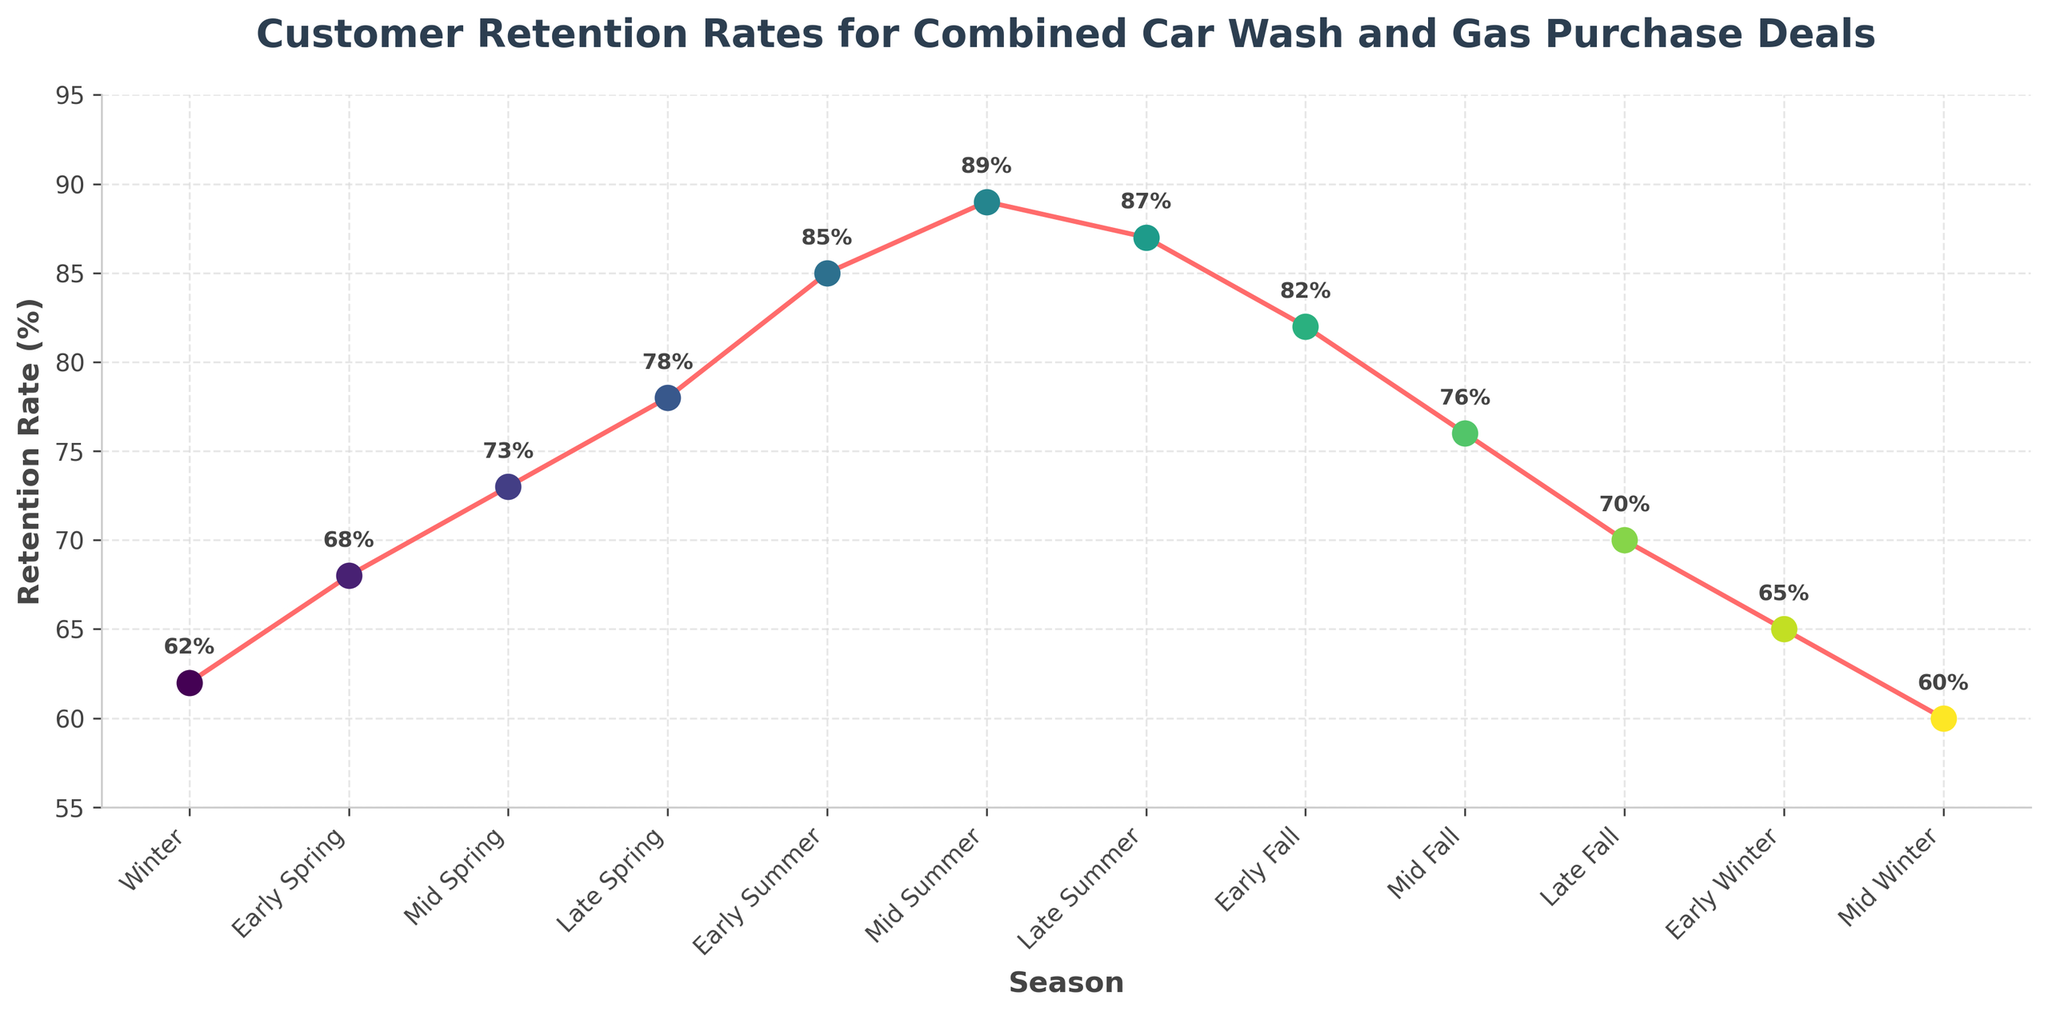What is the retention rate during Early Summer? To find the retention rate during Early Summer, locate the 'Early Summer' point on the x-axis and check the corresponding value on the y-axis.
Answer: 85% Which season has the highest customer retention rate? Look for the peak point on the line chart, which will indicate the highest retention rate on the y-axis. This occurs at 'Mid Summer'.
Answer: Mid Summer How does the retention rate in Late Summer compare to Mid Fall? Locate 'Late Summer' and 'Mid Fall' on the x-axis and compare their corresponding y-axis values. The Late Summer retention rate is 87%, while the Mid Fall retention rate is 76%.
Answer: Late Summer is higher Does customer retention rate increase or decrease from Early Winter to Mid Winter? Identify the points for 'Early Winter' and 'Mid Winter' on the x-axis and observe their y-axis values. The retention rate decreases from 65% to 60%.
Answer: Decrease What is the range of retention rates throughout the year? Find the highest and lowest retention rates on the y-axis. The highest is 89% (Mid Summer) and the lowest is 60% (Mid Winter). Calculate the difference: 89% - 60% = 29%.
Answer: 29% During which seasons do we observe the most rapid increase in retention rates? Look for the steepest upward slopes on the line chart. This occurs from 'Early Summer' to 'Mid Summer', and from 'Late Spring' to 'Early Summer'.
Answer: Early Summer to Mid Summer What is the average retention rate across all the seasons depicted? Sum all the retention rates: 62 + 68 + 73 + 78 + 85 + 89 + 87 + 82 + 76 + 70 + 65 + 60 = 895. Divide by the number of seasons: 895 / 12 ≈ 74.58.
Answer: 74.58% How does the customer retention rate change from Late Spring to Early Fall? Identify points for 'Late Spring' and 'Early Fall', then observe the y-axis values. Compare the values of Late Spring (78%) and Early Fall (82%). The retention rate increases by 4 percentage points.
Answer: Increases by 4% What is the percentage difference in retention rate between Early Winter and Early Spring? Locate and compare the retention rates of Early Winter (65%) and Early Spring (68%). The difference is calculated as (68% - 65%)/65% * 100 ≈ 4.62%.
Answer: 4.62% Which periods show a continuous decline in retention rates? Identify sections where the line consistently slopes downward. This is observed from 'Mid Summer' to 'Mid Winter'.
Answer: Mid Summer to Mid Winter 